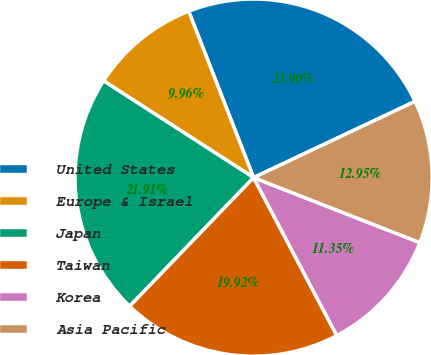Convert chart to OTSL. <chart><loc_0><loc_0><loc_500><loc_500><pie_chart><fcel>United States<fcel>Europe & Israel<fcel>Japan<fcel>Taiwan<fcel>Korea<fcel>Asia Pacific<nl><fcel>23.9%<fcel>9.96%<fcel>21.91%<fcel>19.92%<fcel>11.35%<fcel>12.95%<nl></chart> 